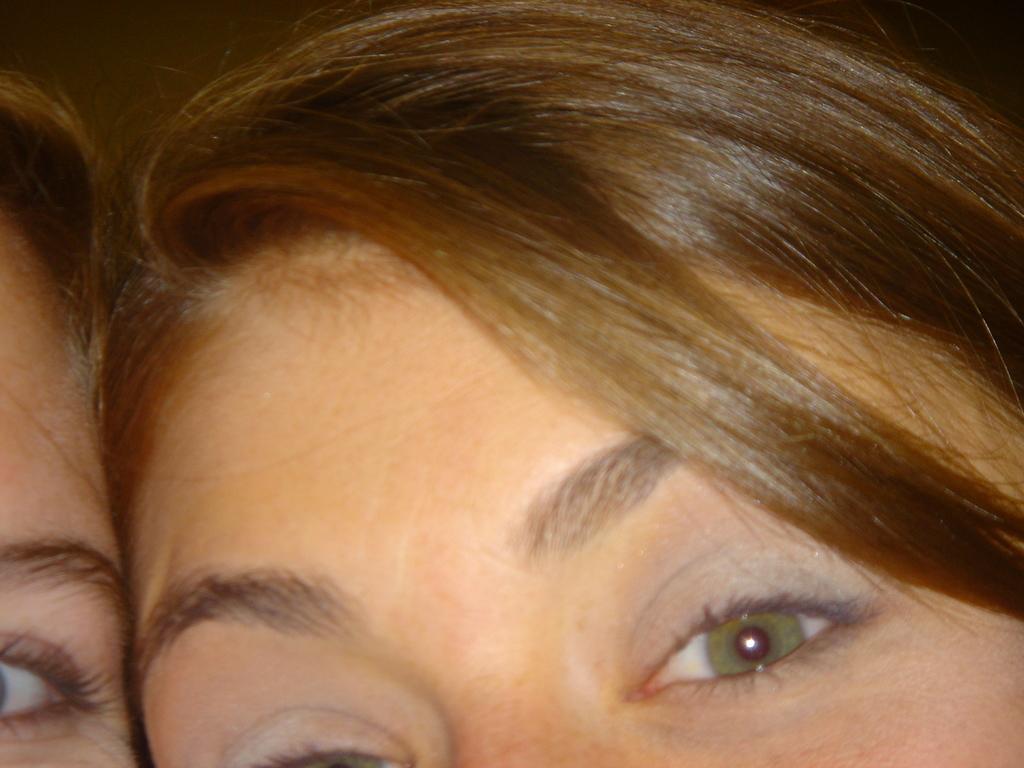Could you give a brief overview of what you see in this image? In this image, I can see the heads of two people. 